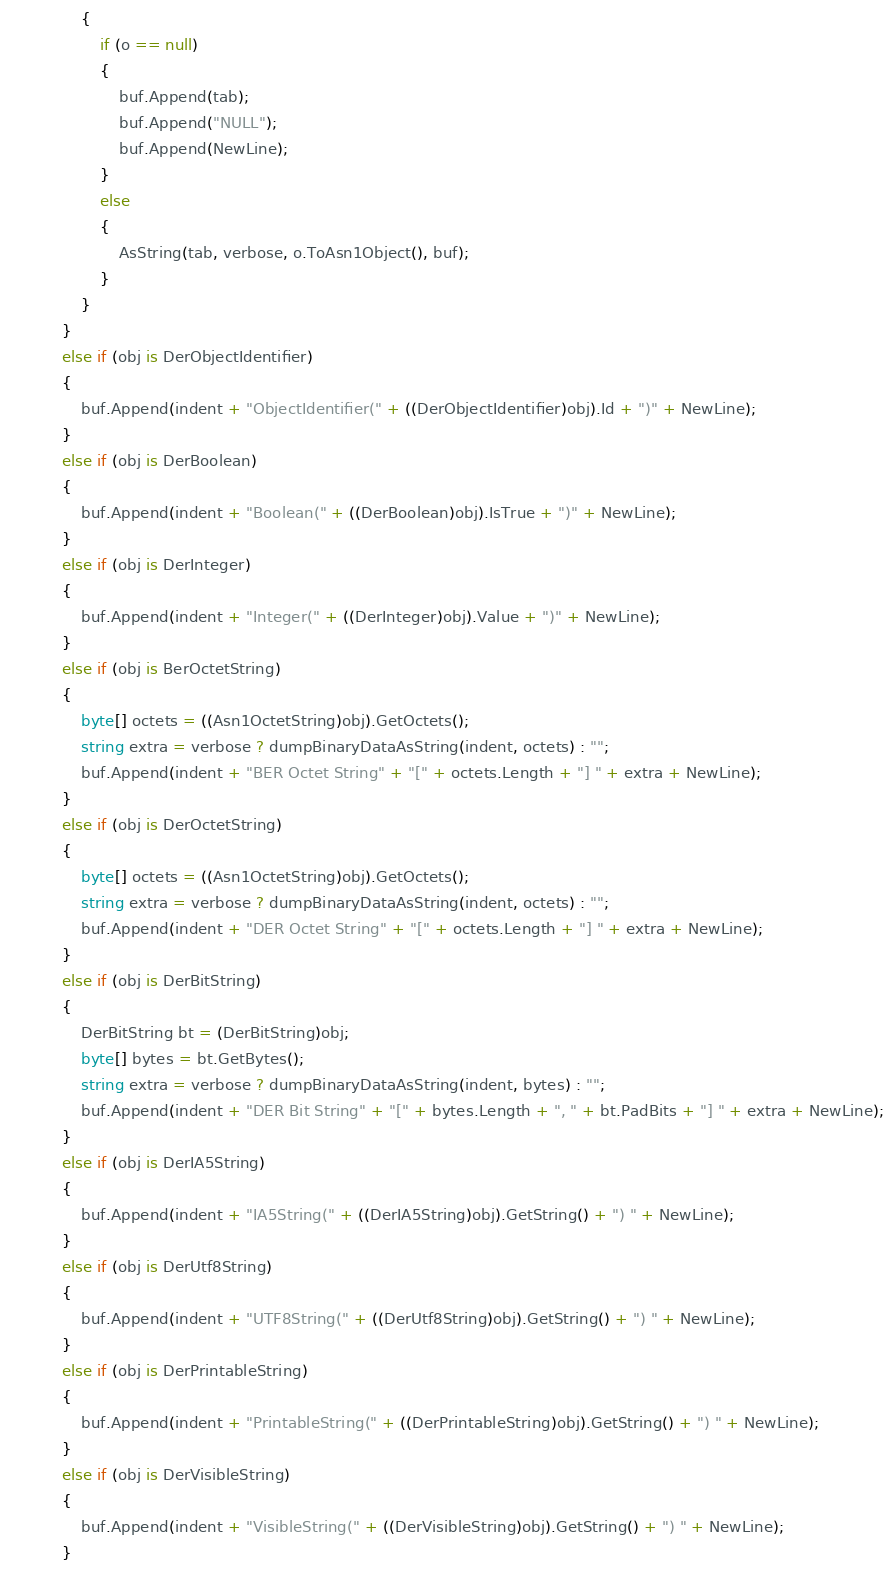<code> <loc_0><loc_0><loc_500><loc_500><_C#_>				{
                    if (o == null)
                    {
                        buf.Append(tab);
                        buf.Append("NULL");
                        buf.Append(NewLine);
                    }
                    else
                    {
                        AsString(tab, verbose, o.ToAsn1Object(), buf);
                    }
                }
            }
            else if (obj is DerObjectIdentifier)
            {
                buf.Append(indent + "ObjectIdentifier(" + ((DerObjectIdentifier)obj).Id + ")" + NewLine);
            }
            else if (obj is DerBoolean)
            {
                buf.Append(indent + "Boolean(" + ((DerBoolean)obj).IsTrue + ")" + NewLine);
            }
            else if (obj is DerInteger)
            {
                buf.Append(indent + "Integer(" + ((DerInteger)obj).Value + ")" + NewLine);
            }
			else if (obj is BerOctetString)
			{
				byte[] octets = ((Asn1OctetString)obj).GetOctets();
				string extra = verbose ? dumpBinaryDataAsString(indent, octets) : "";
				buf.Append(indent + "BER Octet String" + "[" + octets.Length + "] " + extra + NewLine);
			}
            else if (obj is DerOctetString)
            {
				byte[] octets = ((Asn1OctetString)obj).GetOctets();
				string extra = verbose ? dumpBinaryDataAsString(indent, octets) : "";
				buf.Append(indent + "DER Octet String" + "[" + octets.Length + "] " + extra + NewLine);
			}
			else if (obj is DerBitString)
			{
				DerBitString bt = (DerBitString)obj; 
				byte[] bytes = bt.GetBytes();
				string extra = verbose ? dumpBinaryDataAsString(indent, bytes) : "";
				buf.Append(indent + "DER Bit String" + "[" + bytes.Length + ", " + bt.PadBits + "] " + extra + NewLine);
			}
            else if (obj is DerIA5String)
            {
                buf.Append(indent + "IA5String(" + ((DerIA5String)obj).GetString() + ") " + NewLine);
            }
			else if (obj is DerUtf8String)
			{
				buf.Append(indent + "UTF8String(" + ((DerUtf8String)obj).GetString() + ") " + NewLine);
			}
            else if (obj is DerPrintableString)
            {
                buf.Append(indent + "PrintableString(" + ((DerPrintableString)obj).GetString() + ") " + NewLine);
            }
            else if (obj is DerVisibleString)
            {
                buf.Append(indent + "VisibleString(" + ((DerVisibleString)obj).GetString() + ") " + NewLine);
            }</code> 